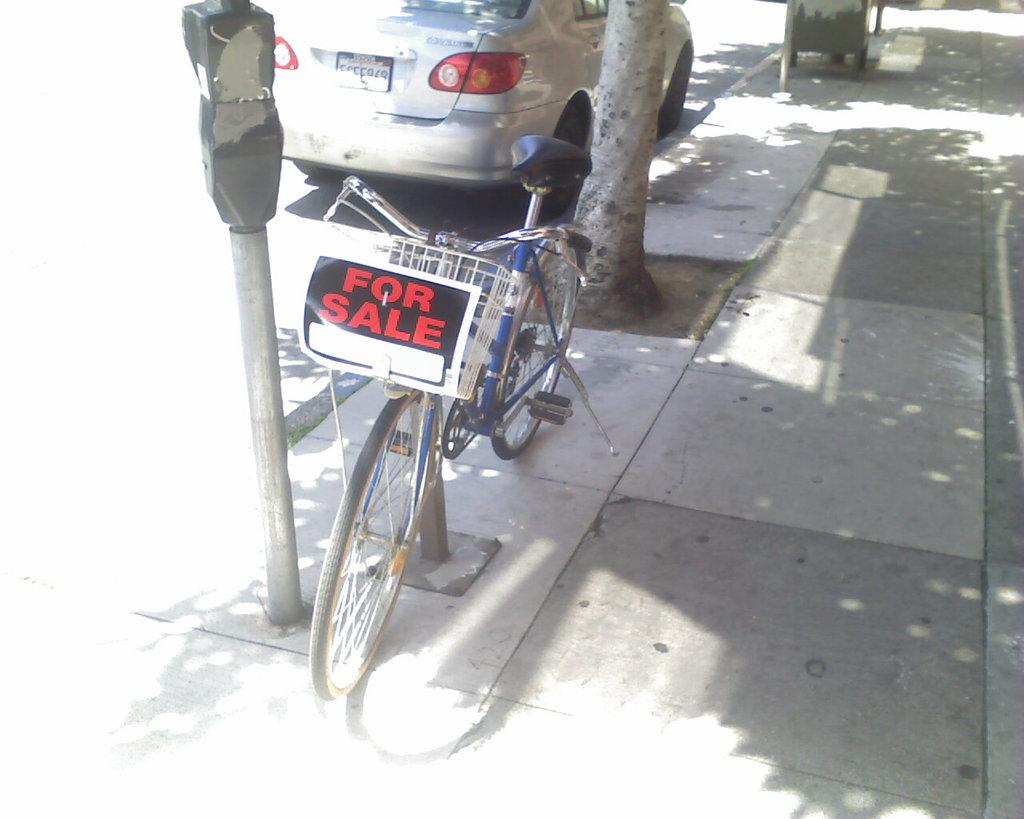What can be seen in the image that people use for transportation? There is a bicycle in the image that people use for transportation. What is on the bicycle? The bicycle has a poster on it. Where is the bicycle located? The bicycle is on the pavement. What else is visible in the image related to transportation? There is a car on the road in the image. What is beside the bicycle? There is a parking meter beside the bicycle. What can be seen behind the bicycle? There is a tree behind the bicycle. What type of property does the letter own in the image? There is no letter or property mentioned in the image. The image only features a bicycle, a poster, a car, a parking meter, and a tree. 